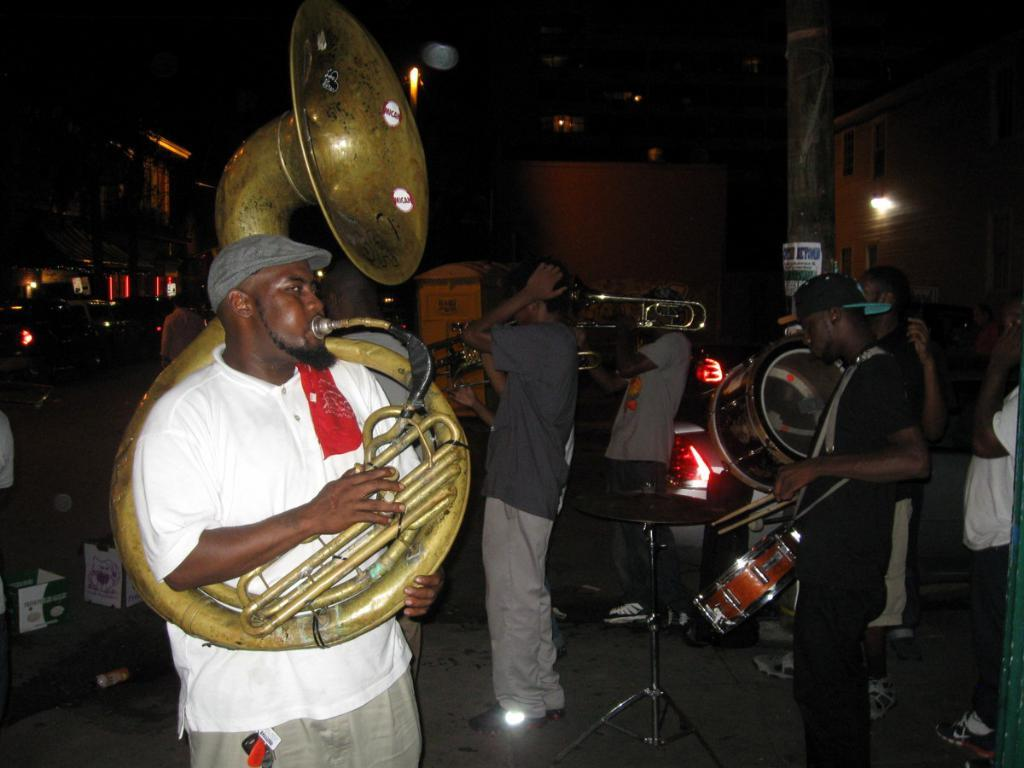How many persons are in the image? There are persons in the image, but the exact number is not specified. What are the persons doing in the image? The persons are likely playing musical instruments, as they are mentioned as being present in the image. What other objects can be seen in the image besides the persons and musical instruments? There are other objects in the image, but their specific nature is not mentioned. What can be seen in the background of the image? In the background of the image, there are buildings, vehicles, and other objects. Where is the drawer located in the image? There is no mention of a drawer in the image, so it cannot be located. How many snakes are slithering around in the image? There is no mention of snakes in the image, so it cannot be determined how many there are. 